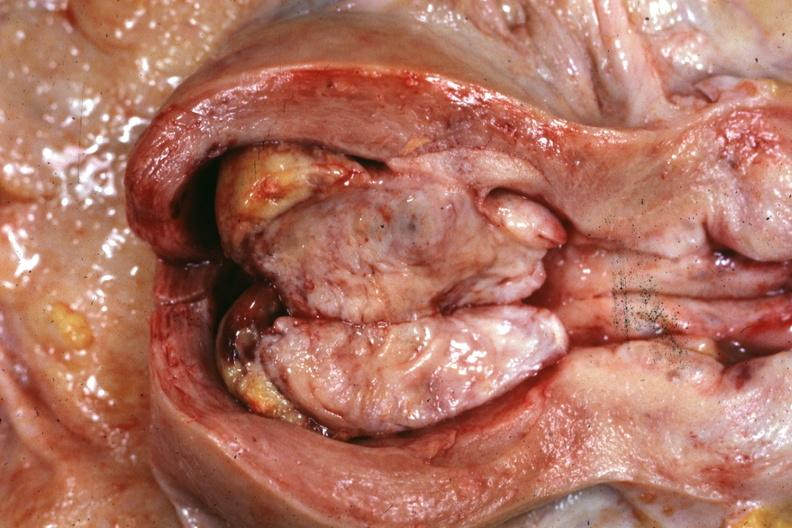what is present?
Answer the question using a single word or phrase. Mixed mesodermal tumor 